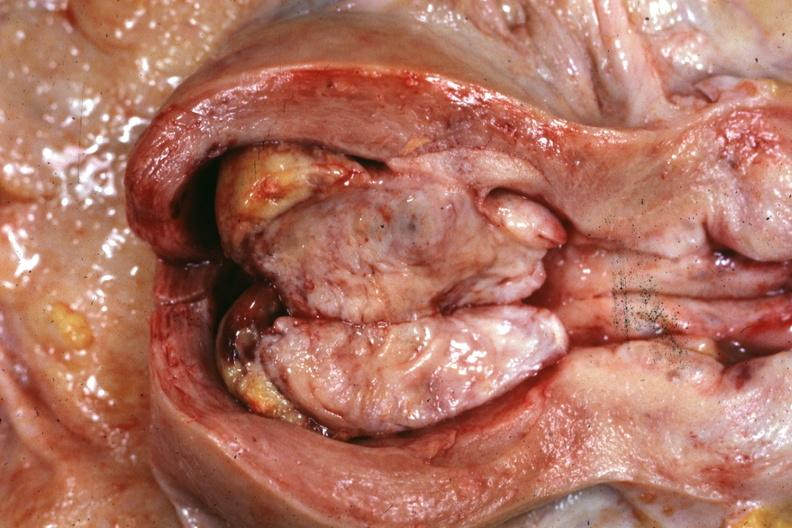what is present?
Answer the question using a single word or phrase. Mixed mesodermal tumor 